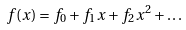Convert formula to latex. <formula><loc_0><loc_0><loc_500><loc_500>f ( x ) = f _ { 0 } + f _ { 1 } x + f _ { 2 } x ^ { 2 } + \dots</formula> 